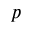<formula> <loc_0><loc_0><loc_500><loc_500>p</formula> 